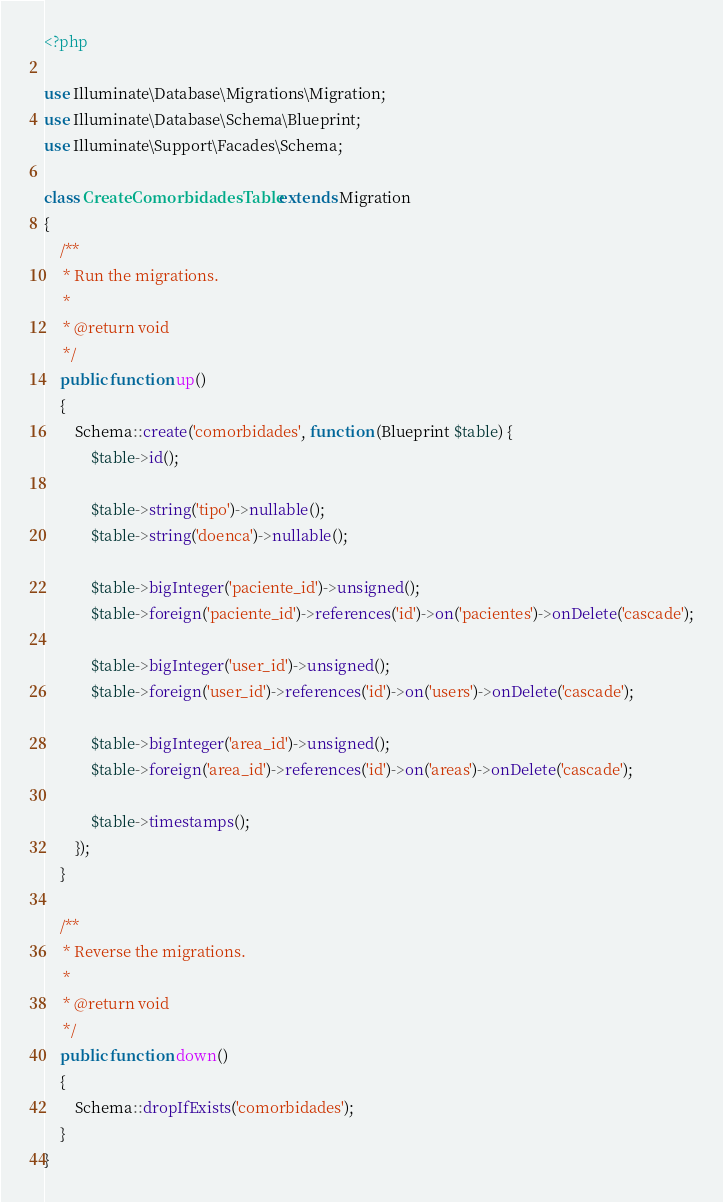<code> <loc_0><loc_0><loc_500><loc_500><_PHP_><?php

use Illuminate\Database\Migrations\Migration;
use Illuminate\Database\Schema\Blueprint;
use Illuminate\Support\Facades\Schema;

class CreateComorbidadesTable extends Migration
{
    /**
     * Run the migrations.
     *
     * @return void
     */
    public function up()
    {
        Schema::create('comorbidades', function (Blueprint $table) {
            $table->id();

            $table->string('tipo')->nullable();
            $table->string('doenca')->nullable();

            $table->bigInteger('paciente_id')->unsigned();
            $table->foreign('paciente_id')->references('id')->on('pacientes')->onDelete('cascade');

            $table->bigInteger('user_id')->unsigned();
            $table->foreign('user_id')->references('id')->on('users')->onDelete('cascade');

            $table->bigInteger('area_id')->unsigned();
            $table->foreign('area_id')->references('id')->on('areas')->onDelete('cascade');

            $table->timestamps();
        });
    }

    /**
     * Reverse the migrations.
     *
     * @return void
     */
    public function down()
    {
        Schema::dropIfExists('comorbidades');
    }
}
</code> 